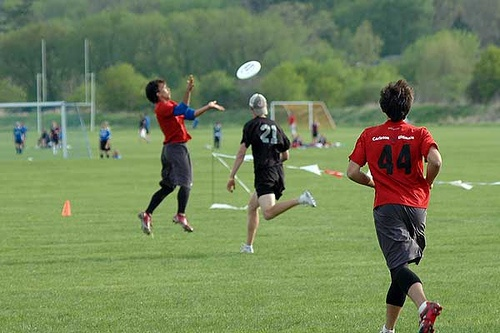Describe the objects in this image and their specific colors. I can see people in gray, black, and maroon tones, people in gray, black, and darkgray tones, people in gray, black, maroon, and navy tones, people in gray and blue tones, and people in gray, black, and darkgray tones in this image. 